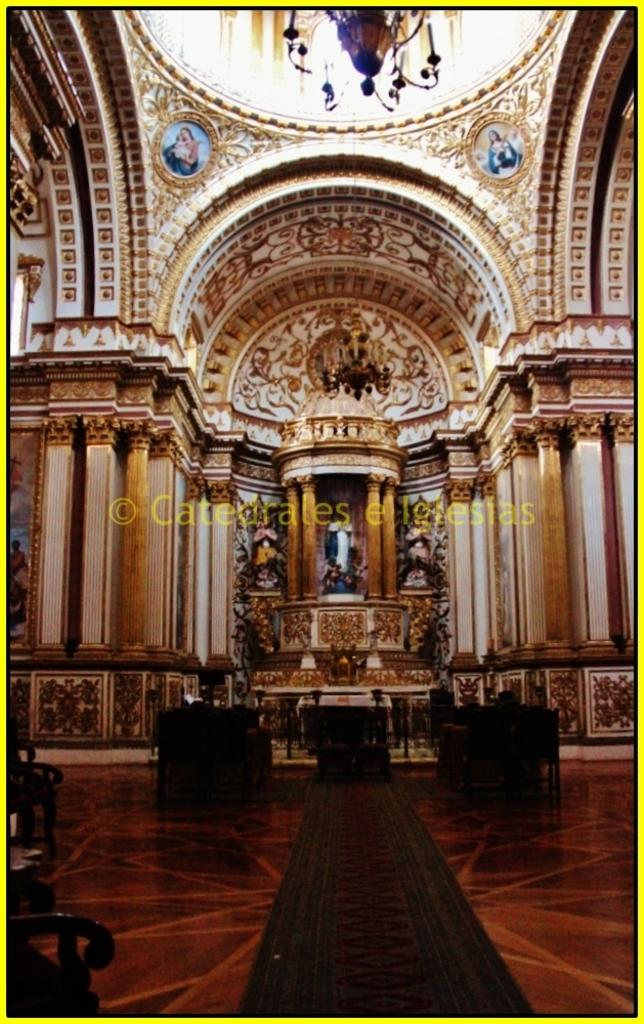What type of location is depicted in the image? The image is an inside view of a church. What architectural features can be seen in the image? There are statues, pillars, and lights visible in the image. What type of seating is present in the image? There are chairs in the image. What is on the floor in the image? There are objects on the floor in the image. What type of glove is being used to clean the linen in the image? There is no glove or linen present in the image; it is an inside view of a church with statues, pillars, chairs, and objects on the floor. What is the aftermath of the event depicted in the image? There is no event depicted in the image, as it is a static view of the inside of a church. 